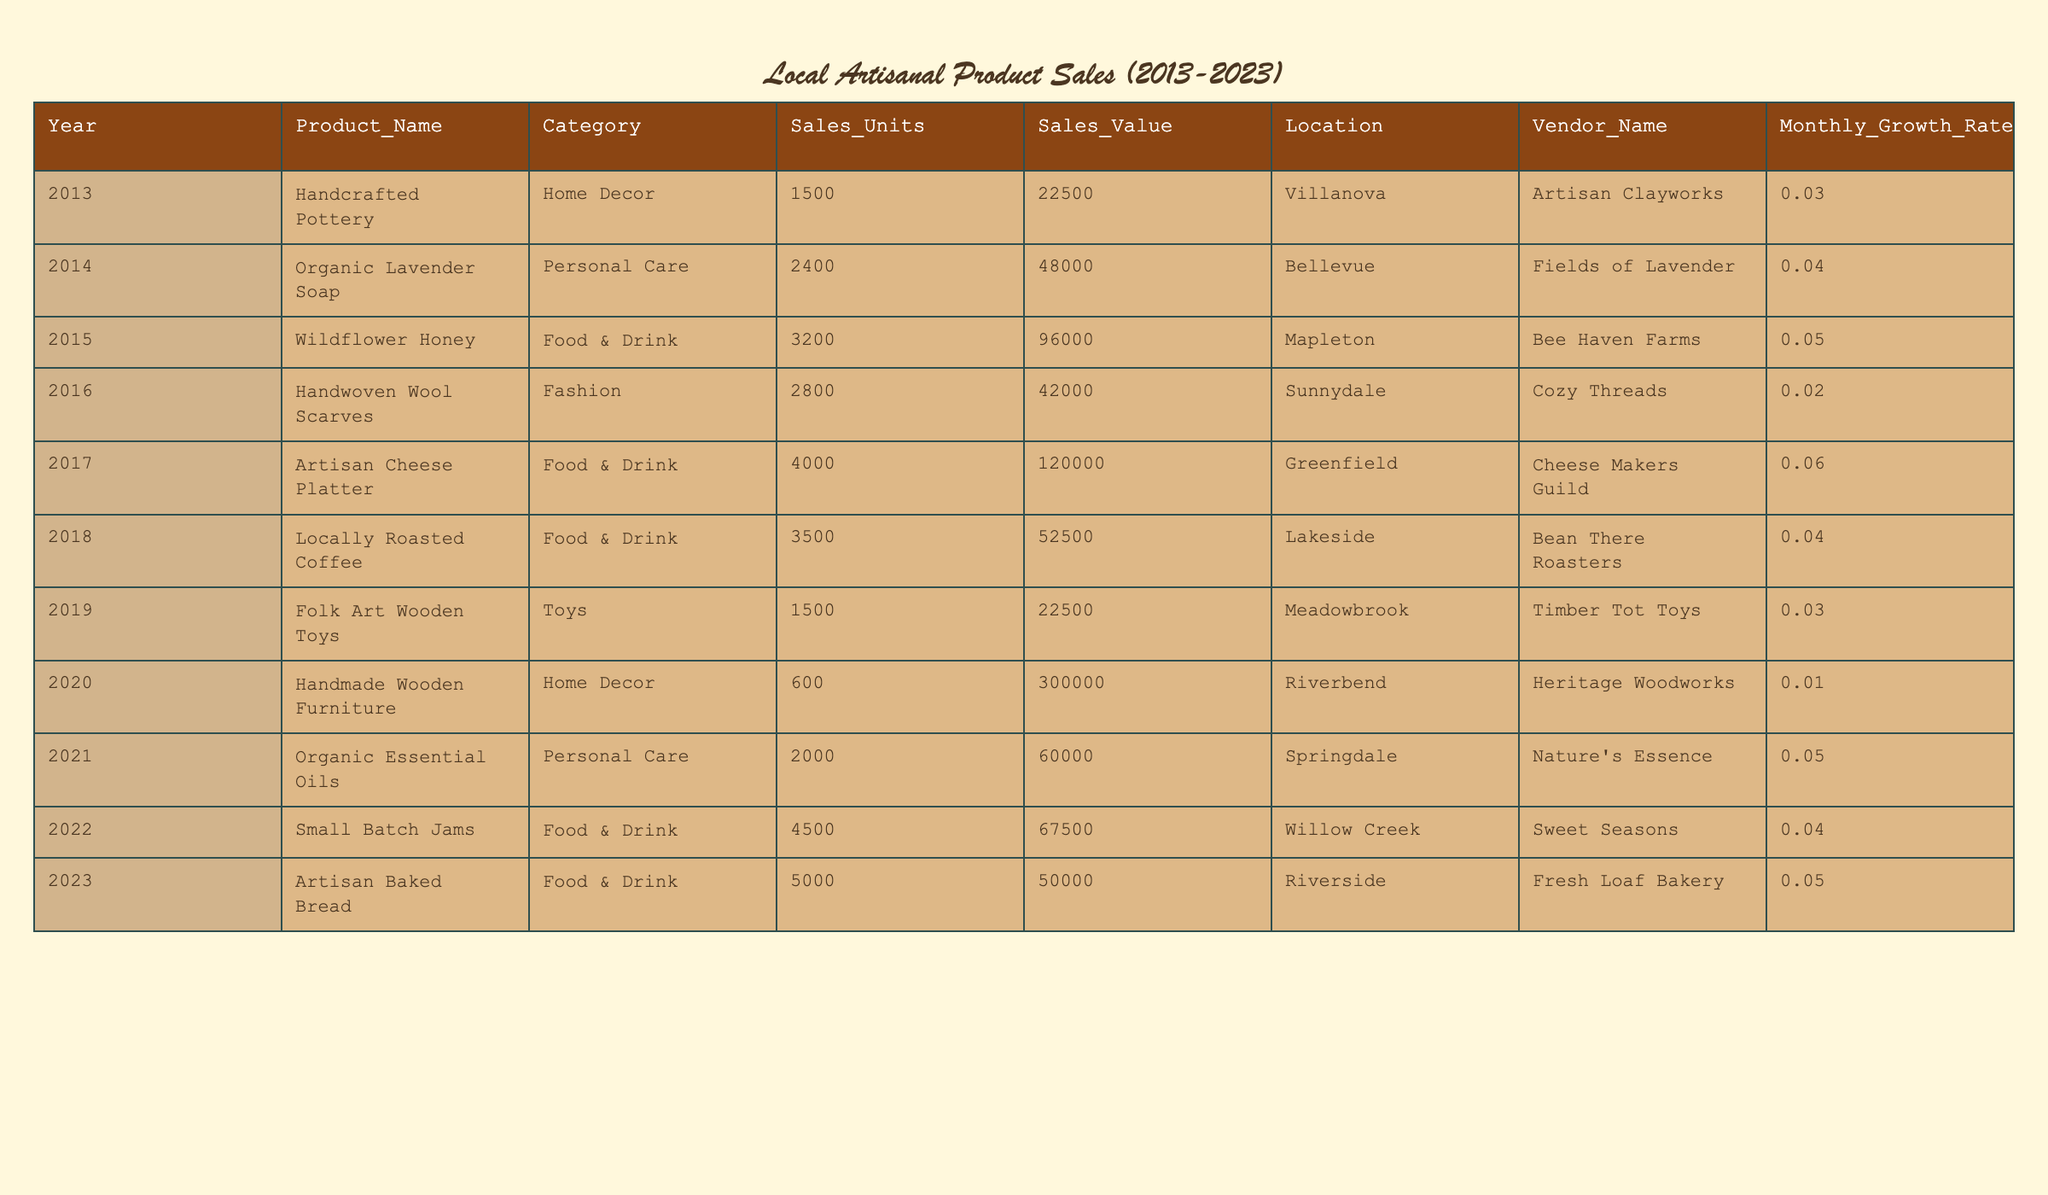What was the highest sales value achieved in a single year? The highest sales value can be found by looking at the 'Sales_Value' column. The values are: 22500, 48000, 96000, 42000, 120000, 52500, 22500, 300000, 60000, 67500, and 50000. The maximum value among these is 300000, achieved in the year 2020.
Answer: 300000 Which product had the highest sales units in one year? In the 'Sales_Units' column, the values are: 1500, 2400, 3200, 2800, 4000, 3500, 1500, 600, 2000, 4500, and 5000. The highest value among these is 6000 units, sold in 2023.
Answer: 5000 Is the average monthly growth rate for Food & Drink products higher than for Home Decor products? For Food & Drink, the monthly growth rates are 0.05, 0.06, 0.04, 0.04, and 0.05, which sums to 0.24 and averages to 0.048. For Home Decor, the rates are 0.03 and 0.01, summing to 0.04 and averaging to 0.02. Since 0.048 is greater than 0.02, the average monthly growth rate for Food & Drink is higher.
Answer: Yes What is the total sales value of all products sold between 2015 and 2022? We sum the sales values from the years 2015 to 2022, which are: 96000 (2015), 42000 (2016), 120000 (2017), 52500 (2018), 60000 (2021), and 67500 (2022). Adding these together gives 96000 + 42000 + 120000 + 52500 + 60000 + 67500 = 426000.
Answer: 426000 Did the location of vendors selling food and drink products mostly differ from home decor products? Food and Drink products were sold in Mapleton, Greenfield, Lakeside, Willow Creek, and Riverside, while Home Decor products were sold in Villanova and Riverbend. Since there are no overlapping locations, we conclude that the locations mostly differ.
Answer: Yes How many more sales units were sold in 2023 compared to 2014? In 2023, 5000 units were sold, and in 2014, 2400 units were sold. To find the difference, we subtract 2400 from 5000, resulting in 5000 - 2400 = 2600 units more sold in 2023.
Answer: 2600 What percentage of the total units sold over the decade were from 'Personal Care' products? The total units sold across all years are 1500 + 2400 + 3200 + 2800 + 4000 + 3500 + 1500 + 600 + 2000 + 4500 + 5000 = 24300. The units for Personal Care are 2400 (2014) and 2000 (2021), totaling 4400. The percentage is (4400 / 24300) * 100 = 18.1%.
Answer: 18.1% Which category had the lowest average monthly growth rate? To find the lowest average monthly growth rate, we consider the rates: Home Decor (0.02), Personal Care (0.045), Food & Drink (0.048), and Toys (0.03). The lowest average is for Home Decor with 0.02.
Answer: Home Decor What was the total sales value of all products sold in 2021 and 2022? The sales values for 2021 are 60000 and for 2022 are 67500. Adding these gives 60000 + 67500 = 127500 total sales value for those years.
Answer: 127500 